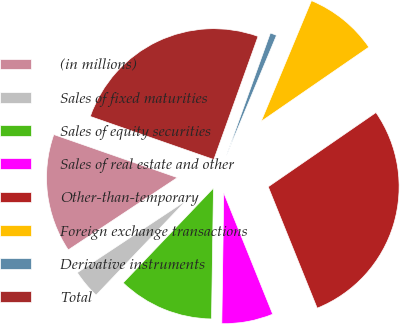Convert chart. <chart><loc_0><loc_0><loc_500><loc_500><pie_chart><fcel>(in millions)<fcel>Sales of fixed maturities<fcel>Sales of equity securities<fcel>Sales of real estate and other<fcel>Other-than-temporary<fcel>Foreign exchange transactions<fcel>Derivative instruments<fcel>Total<nl><fcel>14.65%<fcel>3.57%<fcel>11.88%<fcel>6.34%<fcel>28.5%<fcel>9.11%<fcel>0.8%<fcel>25.14%<nl></chart> 